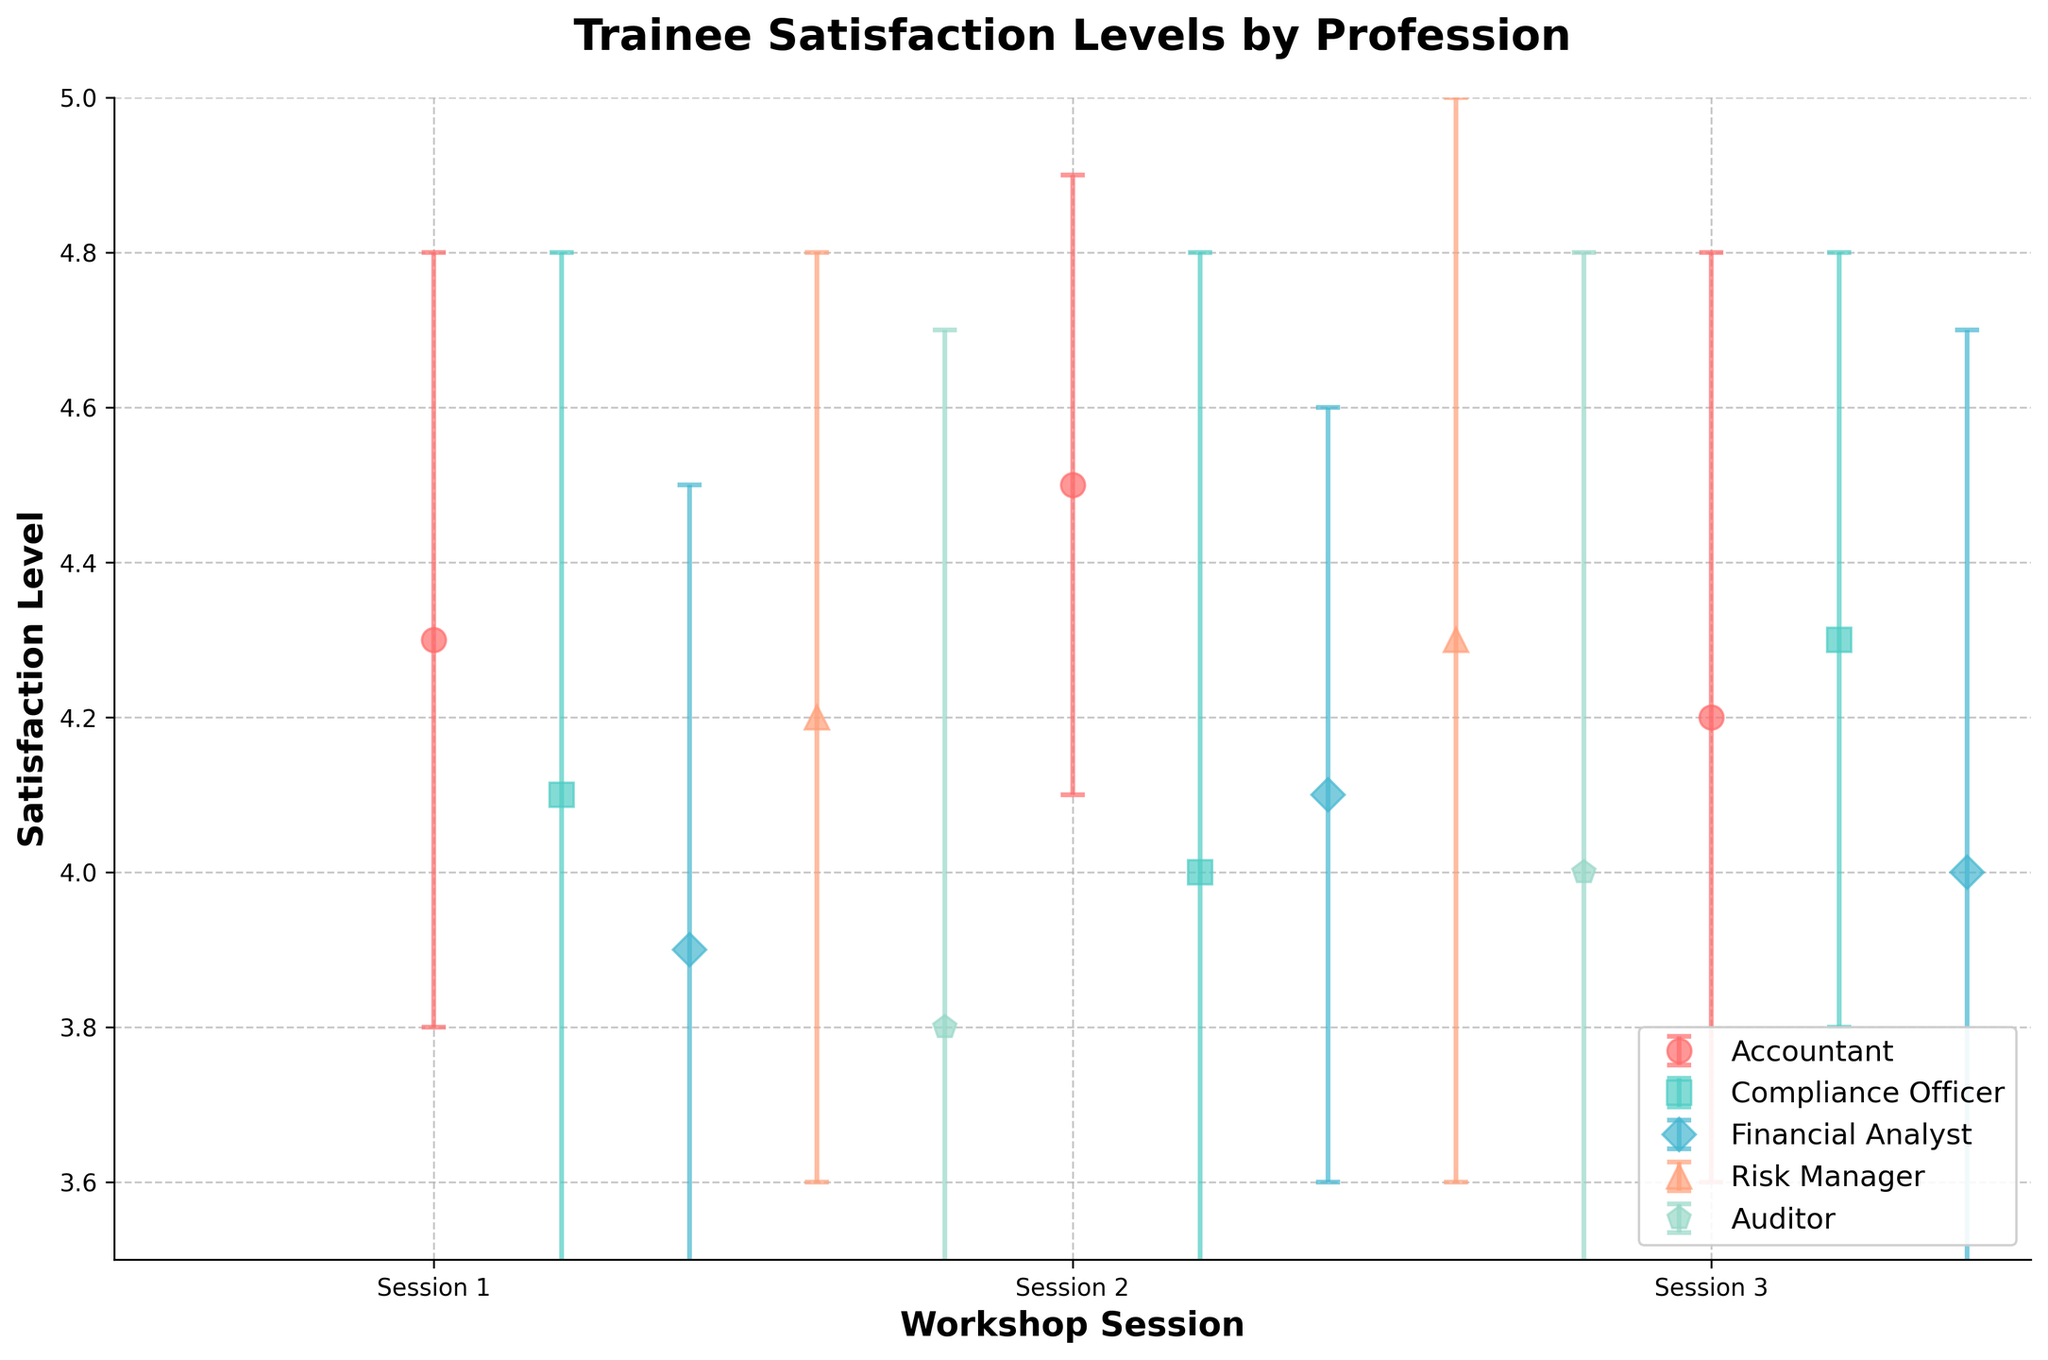What's the title of the plot? The title is written at the top of the plot.
Answer: Trainee Satisfaction Levels by Profession Which profession has the highest average satisfaction level? Comparing the plotted points for each profession, the Accountant has the highest average of satisfaction levels.
Answer: Accountant What's the range of satisfaction levels for Financial Analysts across all workshop sessions? Observing the Financial Analyst data points, the satisfaction levels range from 3.9 to 4.1.
Answer: 3.9 to 4.1 How many workshop sessions are shown in the plot? The x-axis has labels indicating the workshop sessions. There are three session labels on the x-axis.
Answer: 3 What's the lowest satisfaction level recorded, and which profession and session does it belong to? The lowest satisfaction level point on the plot belongs to the Auditor in the first session, with a value of 3.8.
Answer: 3.8, Auditor, Session 1 Which profession shows the highest variability in satisfaction levels? Looking at the error bars, the Auditor profession has the larger error bars indicating higher variability.
Answer: Auditor Is the satisfaction level for Compliance Officers higher in the third session compared to the first session? For Compliance Officers, the satisfaction level in the third session is 4.3, which is higher than 4.1 in the first session.
Answer: Yes Which profession has a consistent satisfaction level across all workshop sessions? By observing the data points and their error bars, Risk Managers show a consistent satisfaction level across all sessions with little variance.
Answer: Risk Manager Among all the professions, which one has the closest average satisfaction level to 4.0 in the second session? Comparing average values in the second session, the satisfaction level closest to 4.0 is Compliance Officer.
Answer: Compliance Officer What is the overall trend of satisfaction levels for Accountants across the three workshop sessions? The trend for Accountants is upward from session 1 to session 2 (4.3 to 4.5) and a slight downward movement from session 2 to session 3 (4.5 to 4.2).
Answer: Upward then slightly downward 